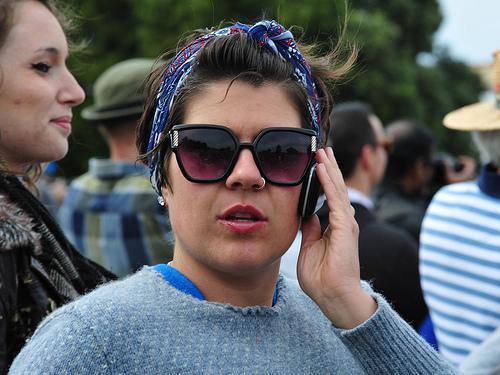How many women are on cell phones?
Give a very brief answer. 1. 